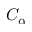<formula> <loc_0><loc_0><loc_500><loc_500>C _ { \alpha }</formula> 